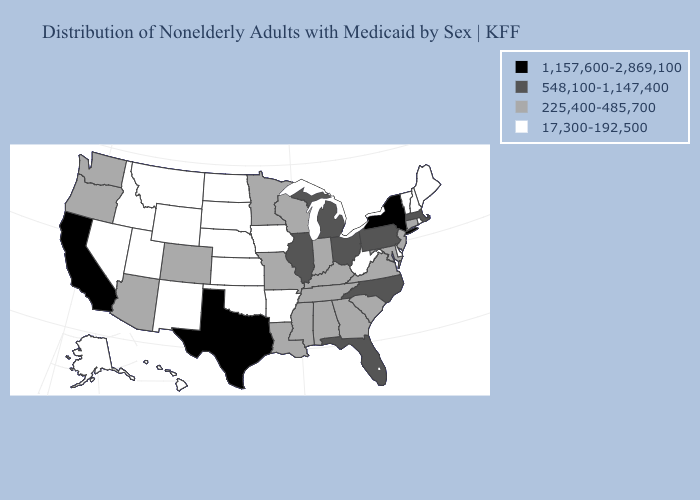Name the states that have a value in the range 225,400-485,700?
Keep it brief. Alabama, Arizona, Colorado, Connecticut, Georgia, Indiana, Kentucky, Louisiana, Maryland, Minnesota, Mississippi, Missouri, New Jersey, Oregon, South Carolina, Tennessee, Virginia, Washington, Wisconsin. Does Arkansas have the same value as Wisconsin?
Give a very brief answer. No. Does Delaware have a lower value than Montana?
Keep it brief. No. Does the first symbol in the legend represent the smallest category?
Short answer required. No. What is the value of Vermont?
Answer briefly. 17,300-192,500. What is the value of Texas?
Quick response, please. 1,157,600-2,869,100. Does Ohio have a higher value than New York?
Be succinct. No. What is the value of Ohio?
Answer briefly. 548,100-1,147,400. Among the states that border West Virginia , does Pennsylvania have the highest value?
Be succinct. Yes. What is the highest value in the Northeast ?
Quick response, please. 1,157,600-2,869,100. What is the value of Kentucky?
Concise answer only. 225,400-485,700. Name the states that have a value in the range 225,400-485,700?
Keep it brief. Alabama, Arizona, Colorado, Connecticut, Georgia, Indiana, Kentucky, Louisiana, Maryland, Minnesota, Mississippi, Missouri, New Jersey, Oregon, South Carolina, Tennessee, Virginia, Washington, Wisconsin. What is the value of Pennsylvania?
Concise answer only. 548,100-1,147,400. Name the states that have a value in the range 17,300-192,500?
Keep it brief. Alaska, Arkansas, Delaware, Hawaii, Idaho, Iowa, Kansas, Maine, Montana, Nebraska, Nevada, New Hampshire, New Mexico, North Dakota, Oklahoma, Rhode Island, South Dakota, Utah, Vermont, West Virginia, Wyoming. Name the states that have a value in the range 225,400-485,700?
Quick response, please. Alabama, Arizona, Colorado, Connecticut, Georgia, Indiana, Kentucky, Louisiana, Maryland, Minnesota, Mississippi, Missouri, New Jersey, Oregon, South Carolina, Tennessee, Virginia, Washington, Wisconsin. 